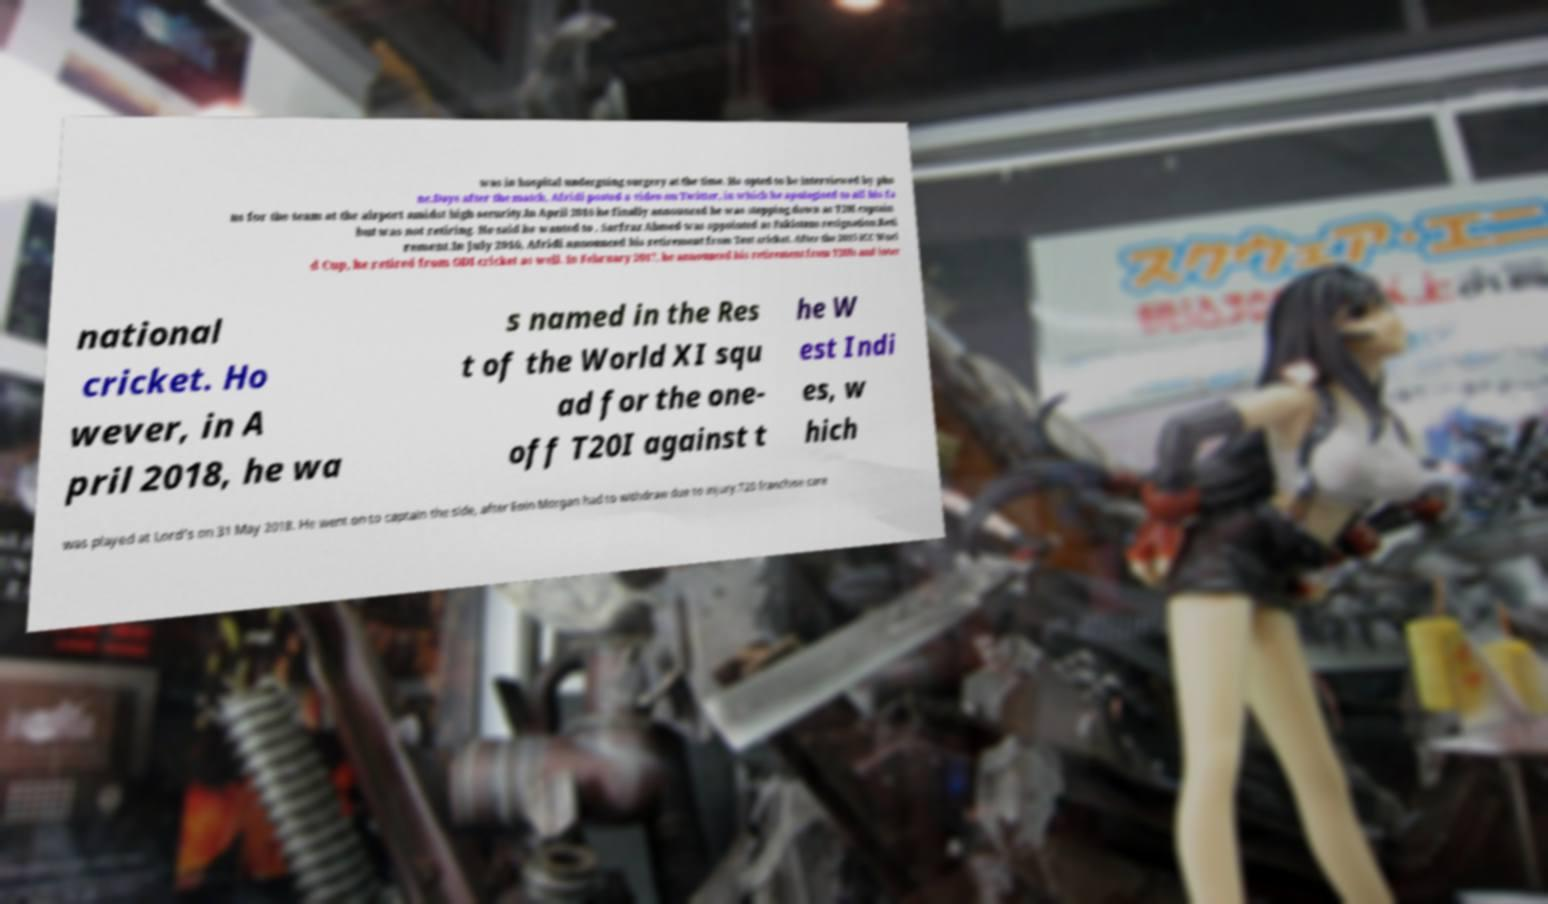I need the written content from this picture converted into text. Can you do that? was in hospital undergoing surgery at the time. He opted to be interviewed by pho ne.Days after the match, Afridi posted a video on Twitter, in which he apologised to all his fa ns for the team at the airport amidst high security.In April 2016 he finally announced he was stepping down as T20I captain but was not retiring. He said he wanted to . Sarfraz Ahmed was appointed as Pakistans resignation.Reti rement.In July 2010, Afridi announced his retirement from Test cricket. After the 2015 ICC Worl d Cup, he retired from ODI cricket as well. In February 2017, he announced his retirement from T20Is and inter national cricket. Ho wever, in A pril 2018, he wa s named in the Res t of the World XI squ ad for the one- off T20I against t he W est Indi es, w hich was played at Lord's on 31 May 2018. He went on to captain the side, after Eoin Morgan had to withdraw due to injury.T20 franchise care 